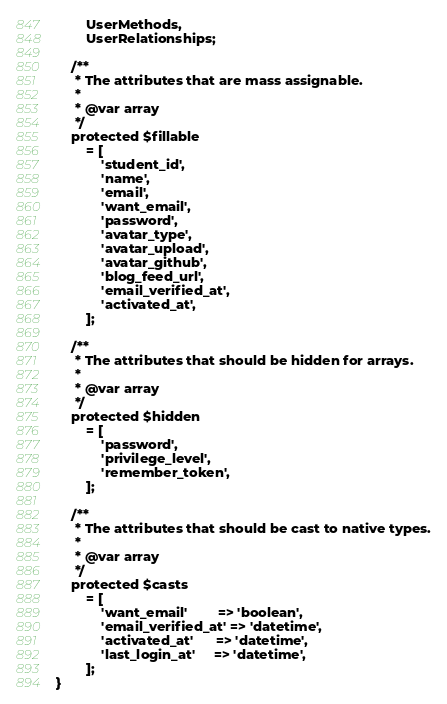<code> <loc_0><loc_0><loc_500><loc_500><_PHP_>        UserMethods,
        UserRelationships;

    /**
     * The attributes that are mass assignable.
     *
     * @var array
     */
    protected $fillable
        = [
            'student_id',
            'name',
            'email',
            'want_email',
            'password',
            'avatar_type',
            'avatar_upload',
            'avatar_github',
            'blog_feed_url',
            'email_verified_at',
            'activated_at',
        ];

    /**
     * The attributes that should be hidden for arrays.
     *
     * @var array
     */
    protected $hidden
        = [
            'password',
            'privilege_level',
            'remember_token',
        ];

    /**
     * The attributes that should be cast to native types.
     *
     * @var array
     */
    protected $casts
        = [
            'want_email'        => 'boolean',
            'email_verified_at' => 'datetime',
            'activated_at'      => 'datetime',
            'last_login_at'     => 'datetime',
        ];
}</code> 